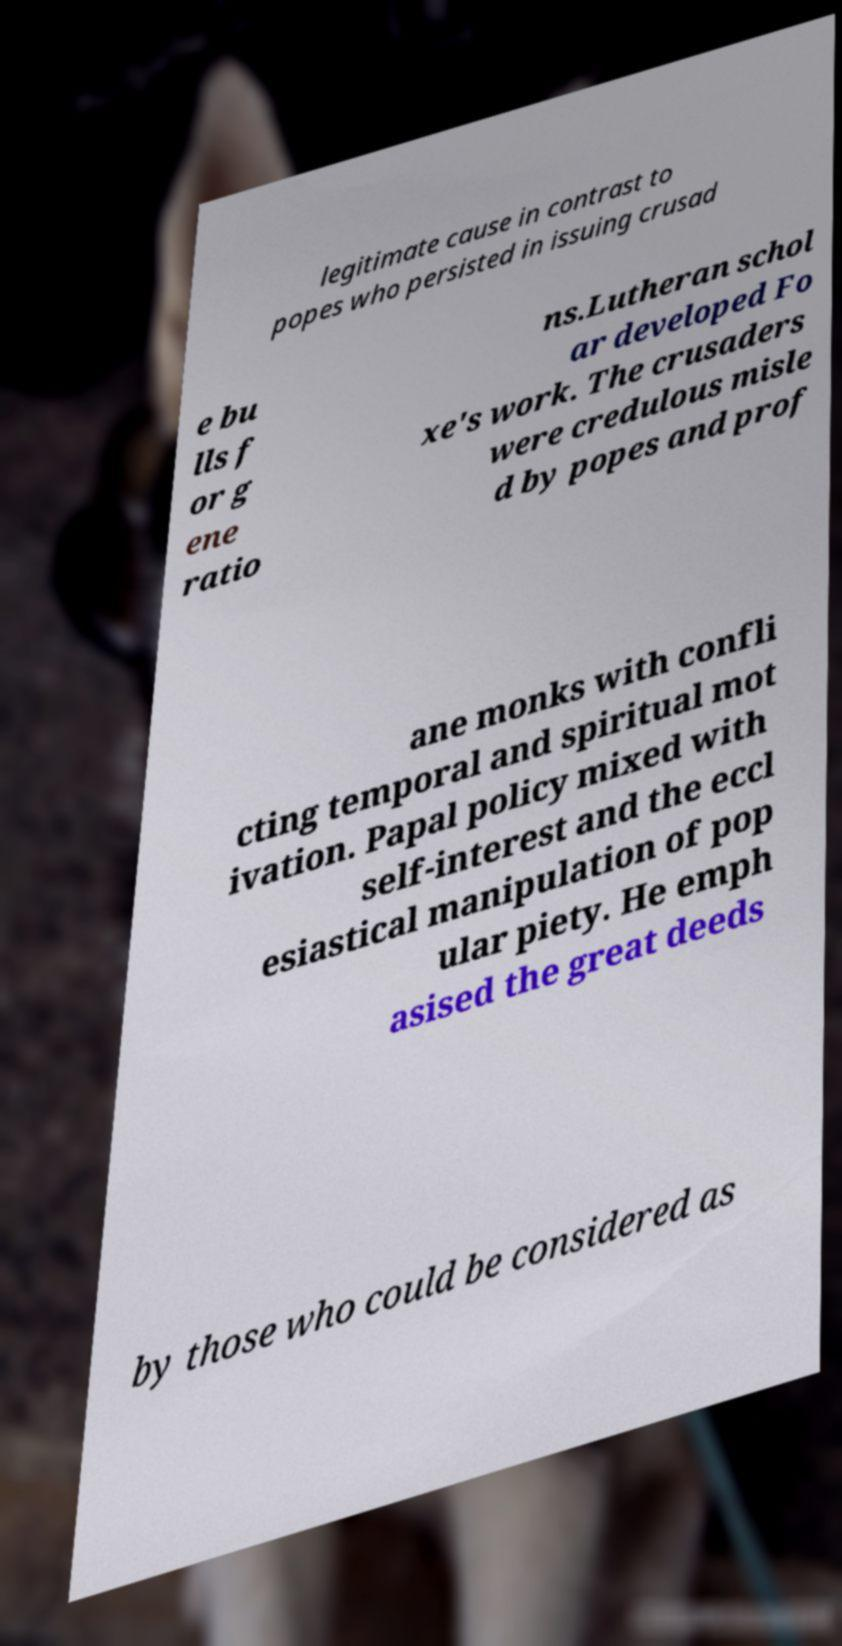I need the written content from this picture converted into text. Can you do that? legitimate cause in contrast to popes who persisted in issuing crusad e bu lls f or g ene ratio ns.Lutheran schol ar developed Fo xe's work. The crusaders were credulous misle d by popes and prof ane monks with confli cting temporal and spiritual mot ivation. Papal policy mixed with self-interest and the eccl esiastical manipulation of pop ular piety. He emph asised the great deeds by those who could be considered as 